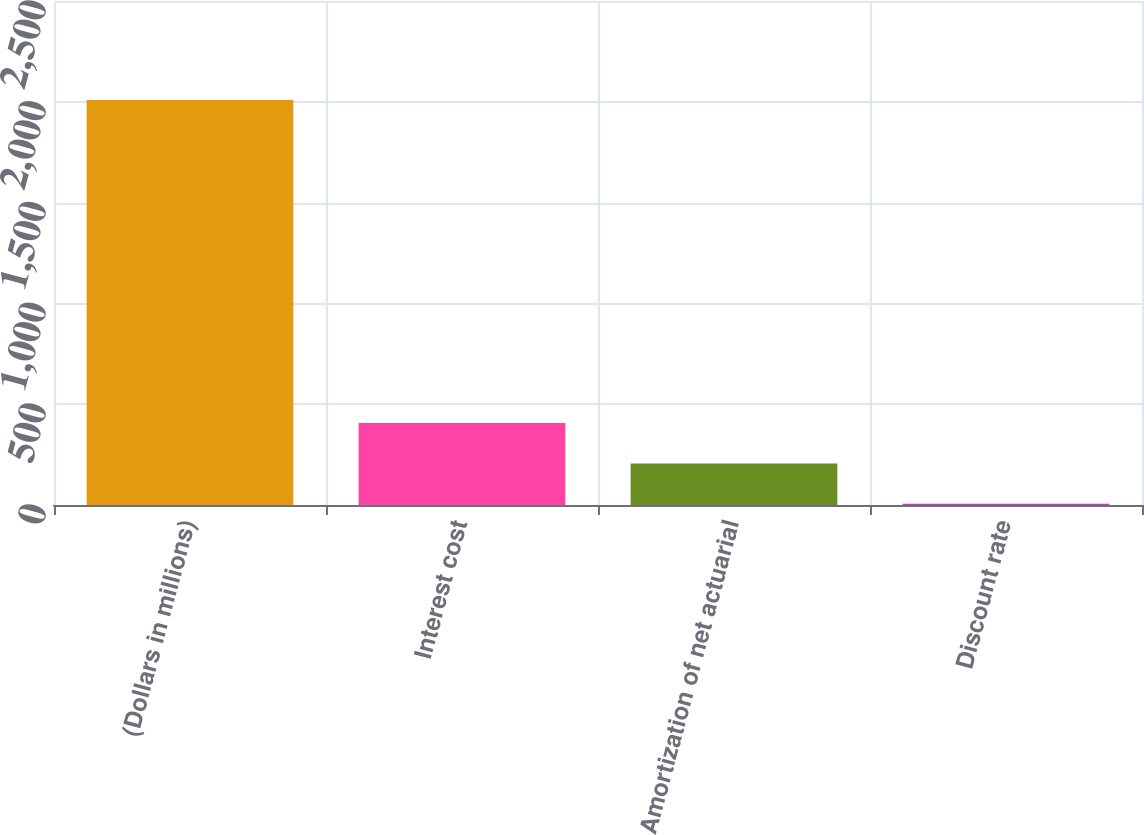Convert chart to OTSL. <chart><loc_0><loc_0><loc_500><loc_500><bar_chart><fcel>(Dollars in millions)<fcel>Interest cost<fcel>Amortization of net actuarial<fcel>Discount rate<nl><fcel>2009<fcel>406.6<fcel>206.3<fcel>6<nl></chart> 